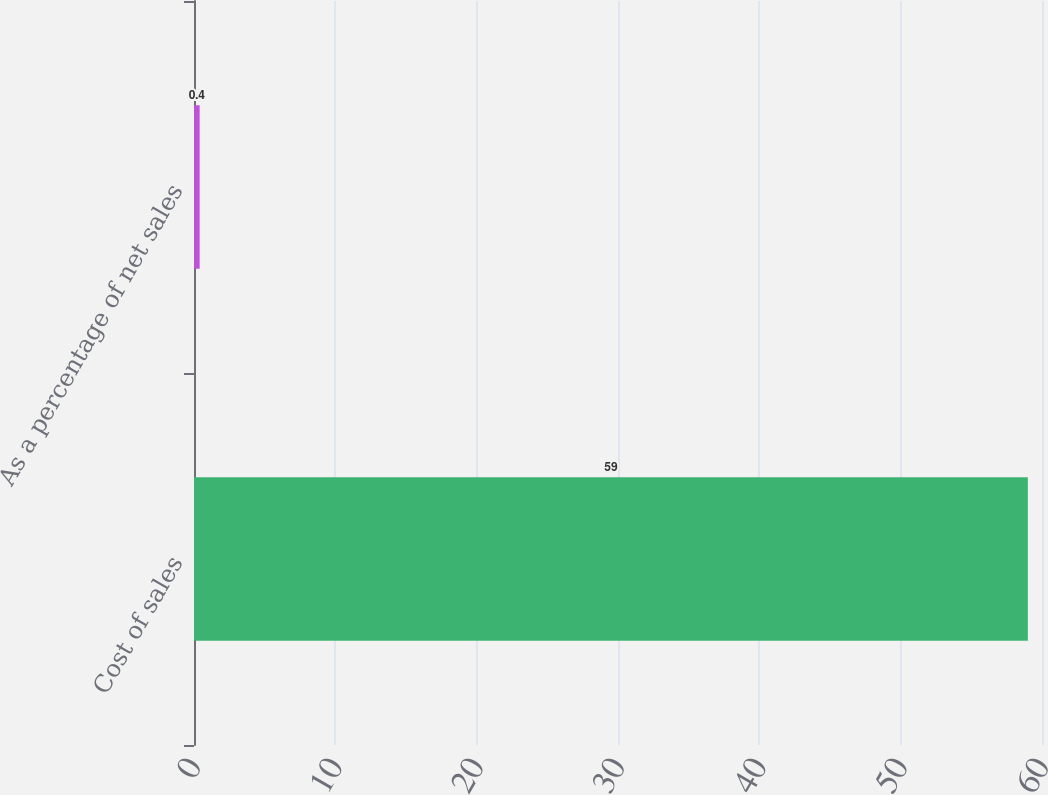<chart> <loc_0><loc_0><loc_500><loc_500><bar_chart><fcel>Cost of sales<fcel>As a percentage of net sales<nl><fcel>59<fcel>0.4<nl></chart> 